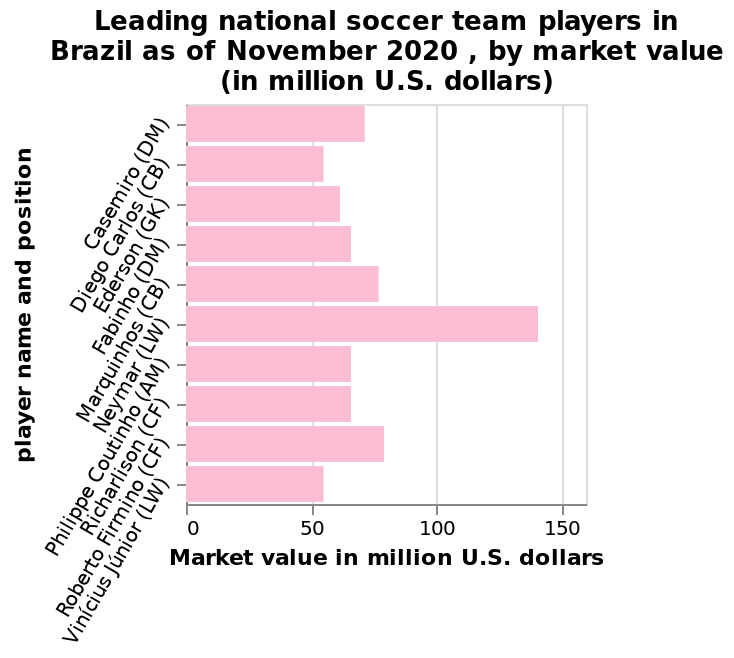<image>
 What is the value of the exceptional player among the top ten?  The exceptional player among the top ten has a value of 140 million. 